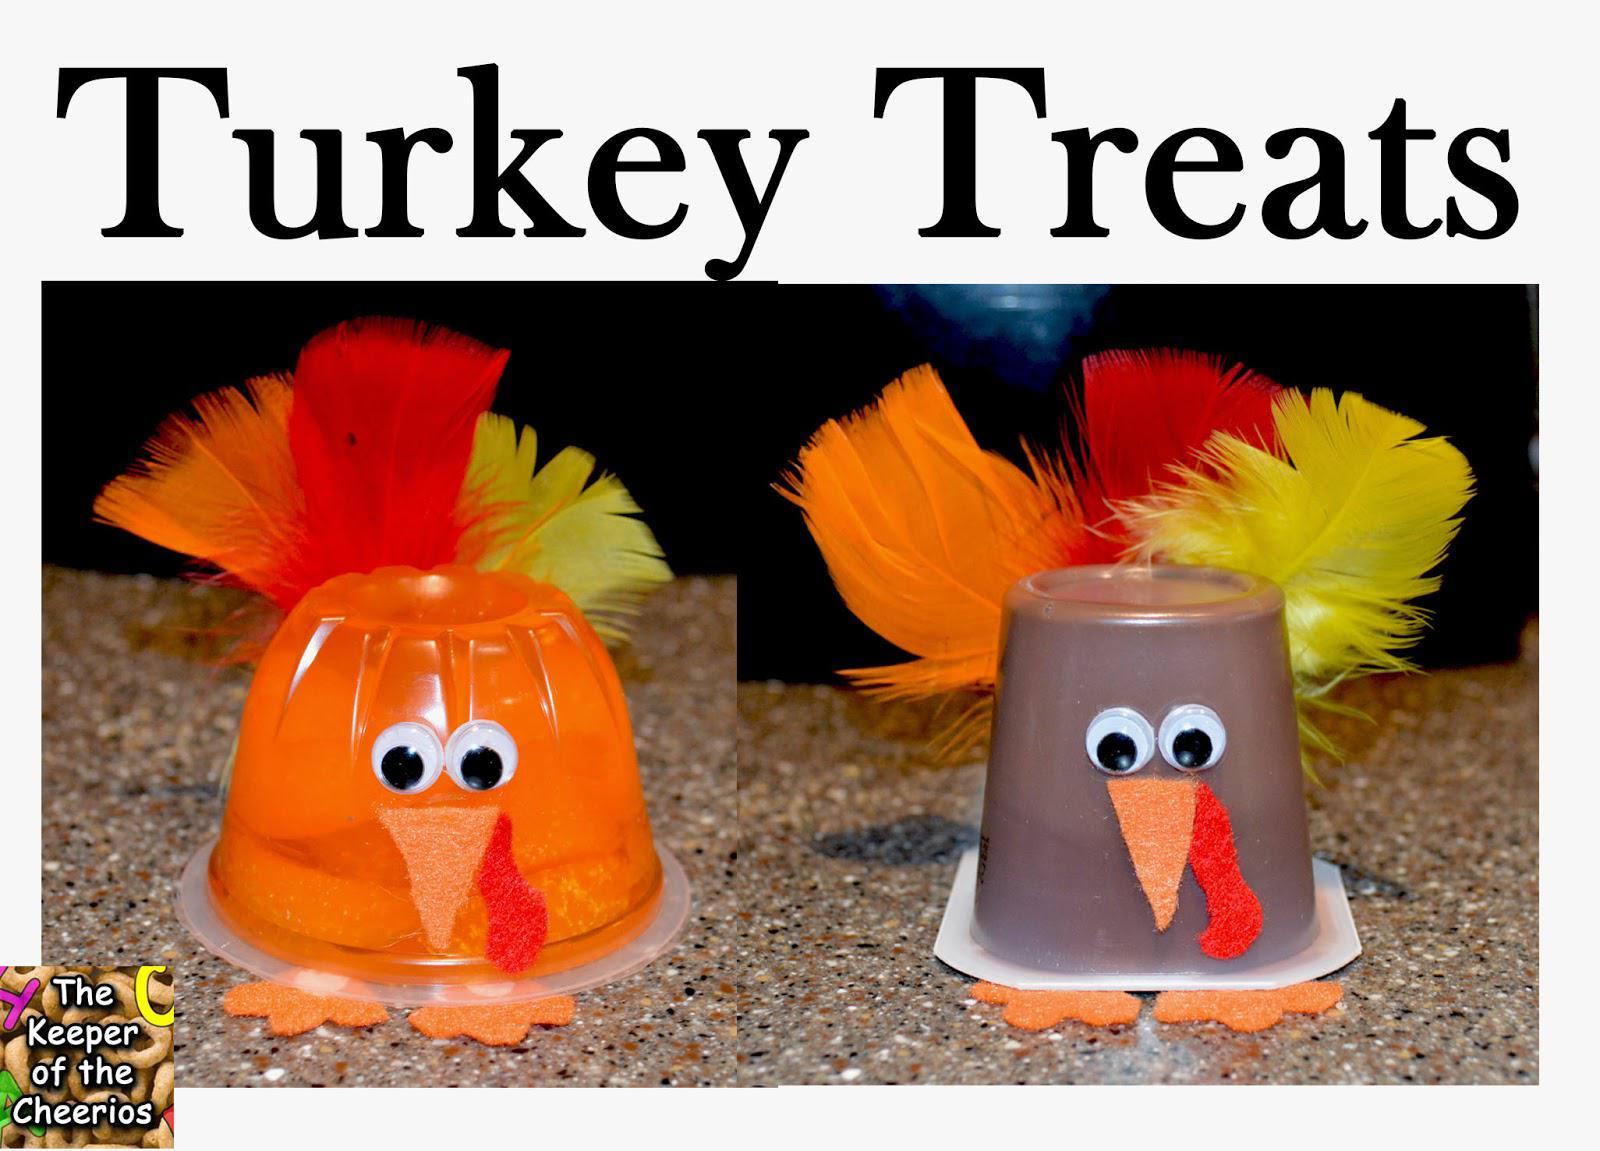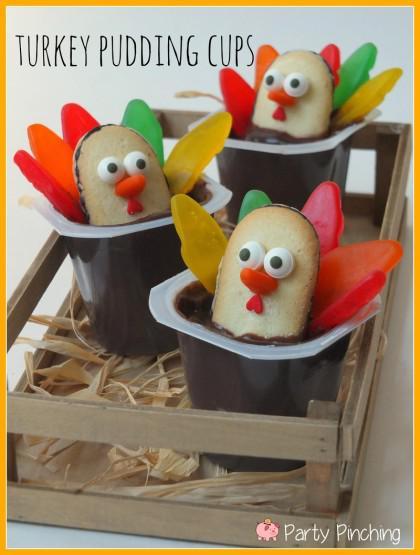The first image is the image on the left, the second image is the image on the right. Analyze the images presented: Is the assertion "The left and right image contains a total of four pudding cups with turkey faces." valid? Answer yes or no. No. The first image is the image on the left, the second image is the image on the right. Given the left and right images, does the statement "One image shows three pudding cup 'turkeys' that are not in a single row, and the other image includes an inverted pudding cup with a turkey face and feathers." hold true? Answer yes or no. Yes. 